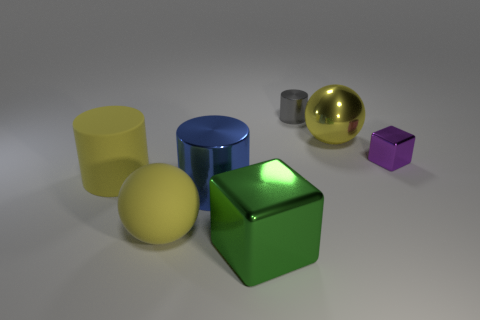Add 2 rubber balls. How many objects exist? 9 Subtract all cylinders. How many objects are left? 4 Add 5 shiny cylinders. How many shiny cylinders are left? 7 Add 1 green blocks. How many green blocks exist? 2 Subtract 1 purple blocks. How many objects are left? 6 Subtract all tiny cylinders. Subtract all big blue metallic cylinders. How many objects are left? 5 